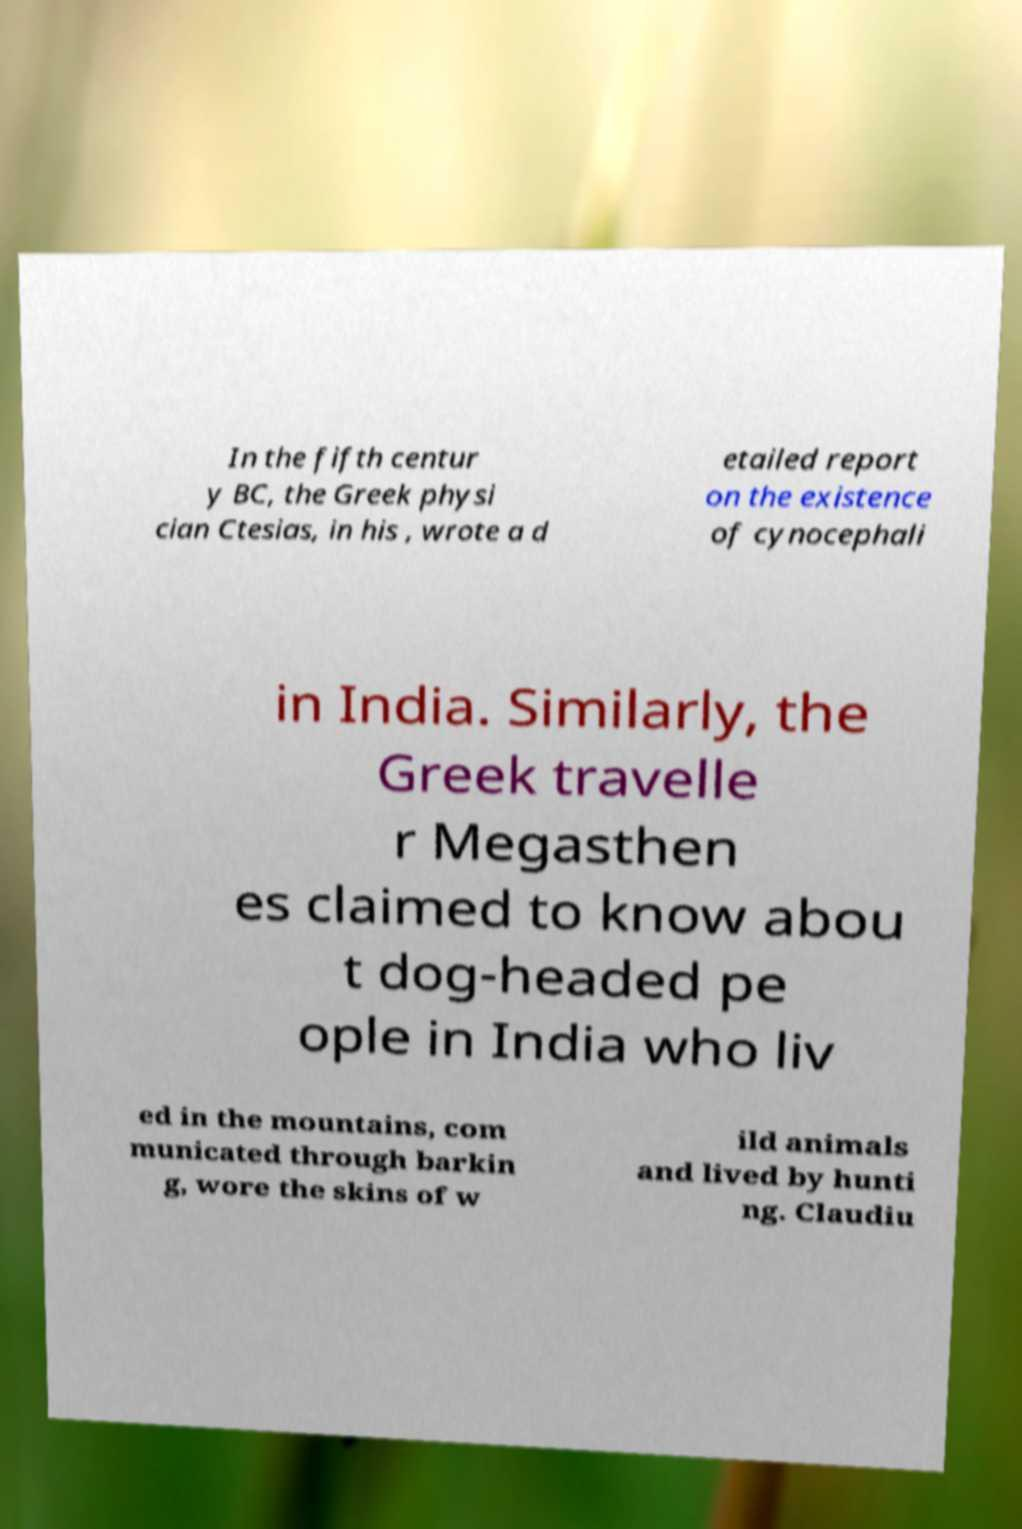Could you extract and type out the text from this image? In the fifth centur y BC, the Greek physi cian Ctesias, in his , wrote a d etailed report on the existence of cynocephali in India. Similarly, the Greek travelle r Megasthen es claimed to know abou t dog-headed pe ople in India who liv ed in the mountains, com municated through barkin g, wore the skins of w ild animals and lived by hunti ng. Claudiu 